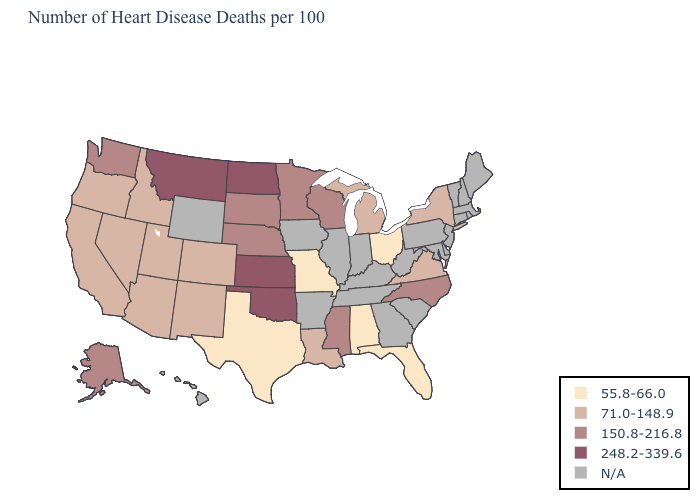How many symbols are there in the legend?
Concise answer only. 5. What is the value of Washington?
Keep it brief. 150.8-216.8. What is the highest value in the USA?
Be succinct. 248.2-339.6. What is the value of Florida?
Be succinct. 55.8-66.0. What is the lowest value in the MidWest?
Give a very brief answer. 55.8-66.0. What is the value of Idaho?
Give a very brief answer. 71.0-148.9. Does Virginia have the highest value in the South?
Quick response, please. No. Does the first symbol in the legend represent the smallest category?
Be succinct. Yes. Does Texas have the lowest value in the USA?
Quick response, please. Yes. Which states hav the highest value in the Northeast?
Be succinct. New York. What is the value of South Dakota?
Keep it brief. 150.8-216.8. Does the map have missing data?
Answer briefly. Yes. Name the states that have a value in the range 71.0-148.9?
Concise answer only. Arizona, California, Colorado, Idaho, Louisiana, Michigan, Nevada, New Mexico, New York, Oregon, Utah, Virginia. Among the states that border Connecticut , which have the lowest value?
Be succinct. New York. Which states have the lowest value in the USA?
Keep it brief. Alabama, Florida, Missouri, Ohio, Texas. 